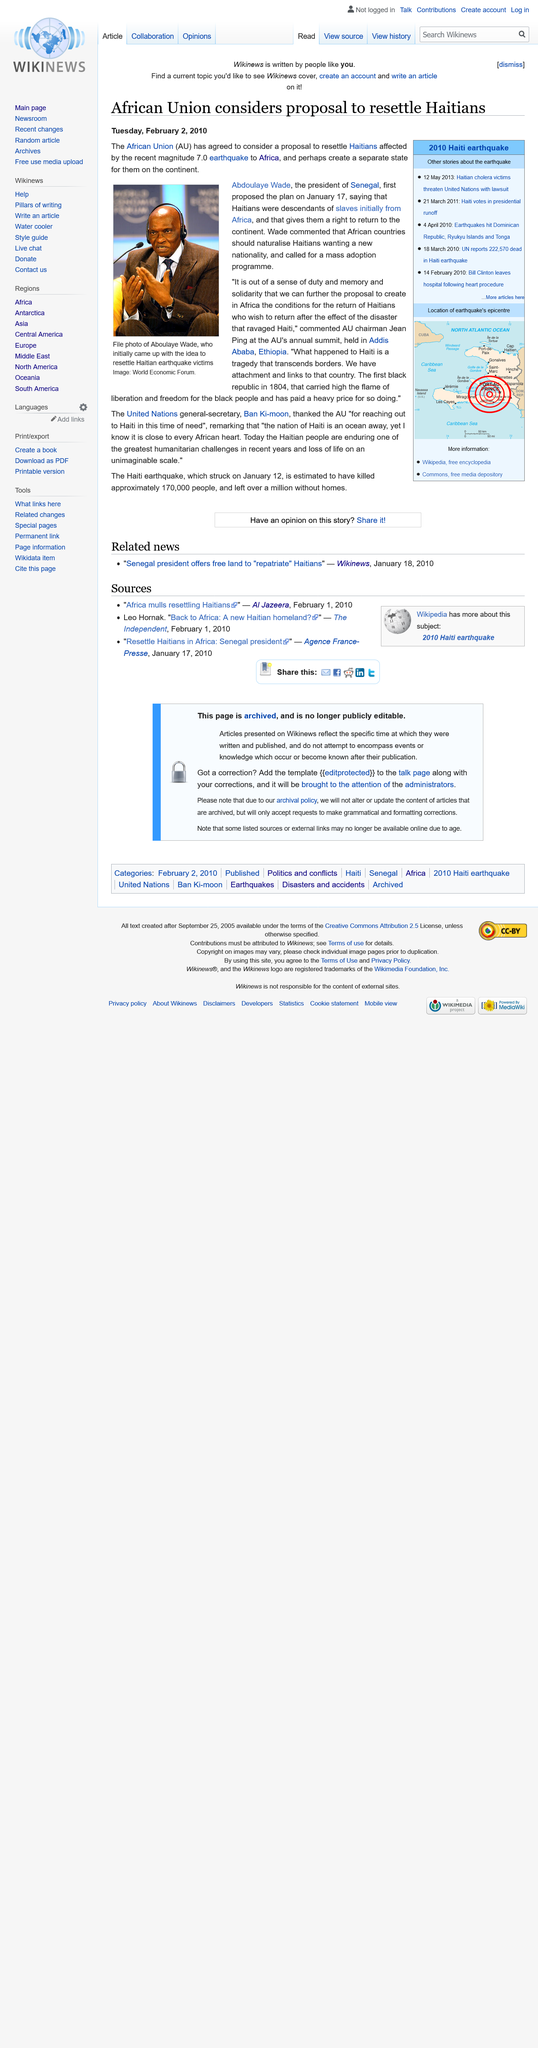Identify some key points in this picture. The African Union has agreed to consider a proposal to resettle Haitians affected by the recent magnitude 7.0 earthquake in Africa. Aboulaye Wade, the inventor of the idea, proposed to resettle the Haitian earthquake victims. The file photo in question features Aboulaye Wade, who initially proposed the idea of resettling Haitian earthquake victims. 